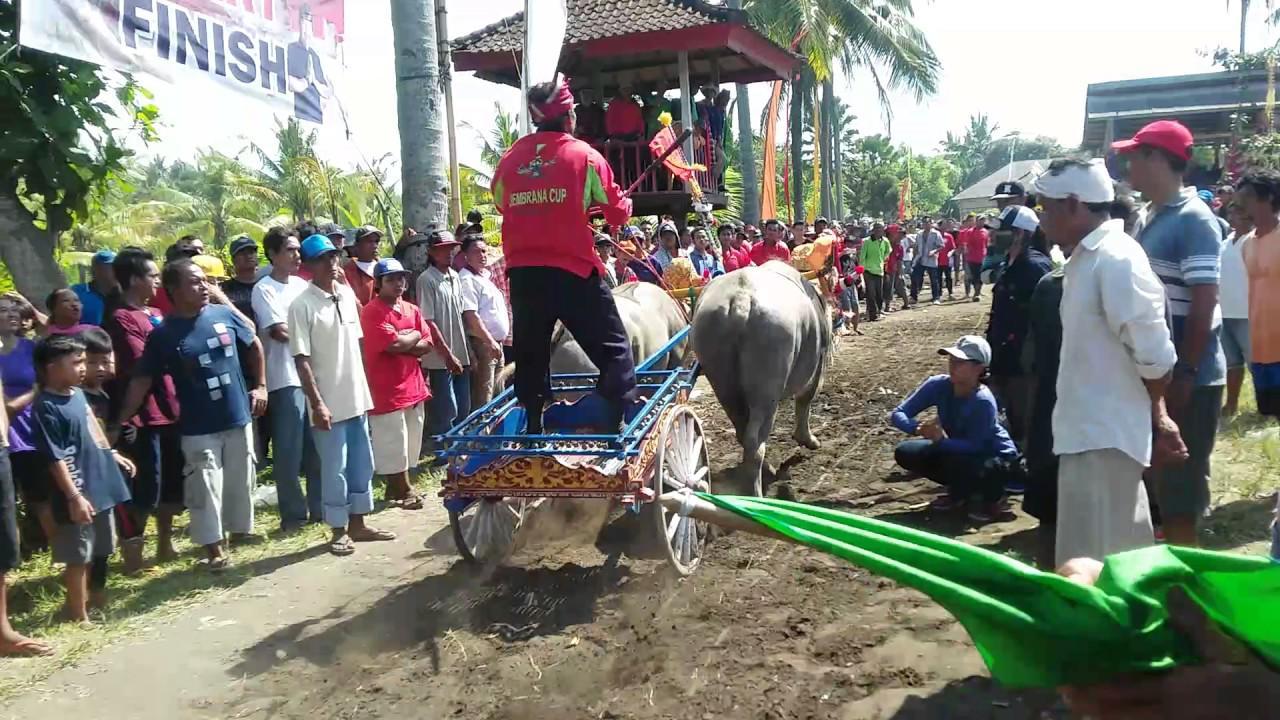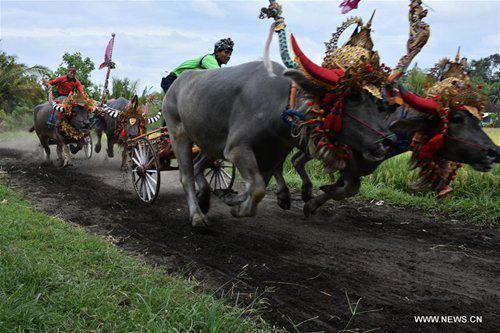The first image is the image on the left, the second image is the image on the right. For the images shown, is this caption "in at least one image there are two black bull in red headdress running right attached to a chaireate." true? Answer yes or no. Yes. The first image is the image on the left, the second image is the image on the right. Considering the images on both sides, is "In the right image, two ox-cart racers in green shirts are driving teams of two non-black oxen to the right." valid? Answer yes or no. No. 